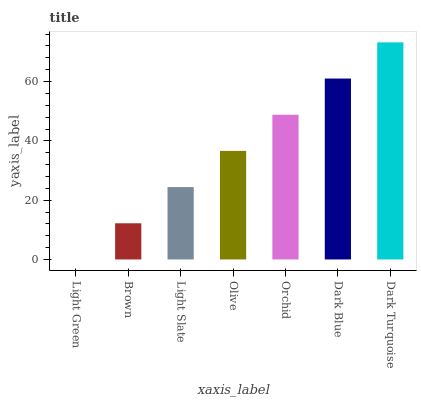Is Light Green the minimum?
Answer yes or no. Yes. Is Dark Turquoise the maximum?
Answer yes or no. Yes. Is Brown the minimum?
Answer yes or no. No. Is Brown the maximum?
Answer yes or no. No. Is Brown greater than Light Green?
Answer yes or no. Yes. Is Light Green less than Brown?
Answer yes or no. Yes. Is Light Green greater than Brown?
Answer yes or no. No. Is Brown less than Light Green?
Answer yes or no. No. Is Olive the high median?
Answer yes or no. Yes. Is Olive the low median?
Answer yes or no. Yes. Is Dark Turquoise the high median?
Answer yes or no. No. Is Light Green the low median?
Answer yes or no. No. 